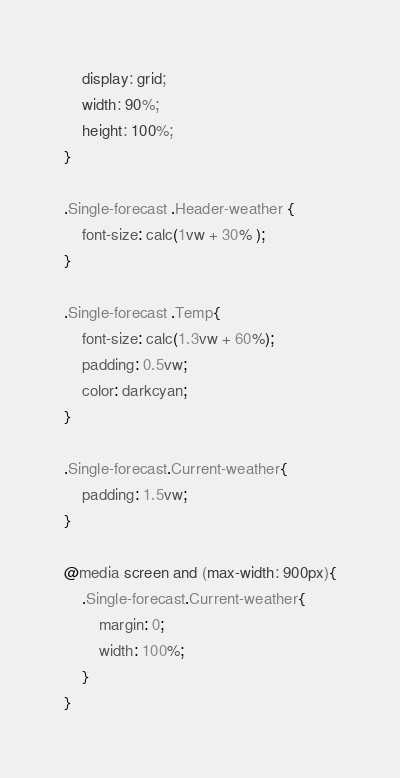Convert code to text. <code><loc_0><loc_0><loc_500><loc_500><_CSS_>    display: grid;
    width: 90%;
    height: 100%;
}

.Single-forecast .Header-weather {
    font-size: calc(1vw + 30% );
}

.Single-forecast .Temp{
    font-size: calc(1.3vw + 60%);
    padding: 0.5vw;
    color: darkcyan;
}

.Single-forecast.Current-weather{
    padding: 1.5vw;
}

@media screen and (max-width: 900px){
    .Single-forecast.Current-weather{ 
        margin: 0;
        width: 100%;
    }
}
</code> 